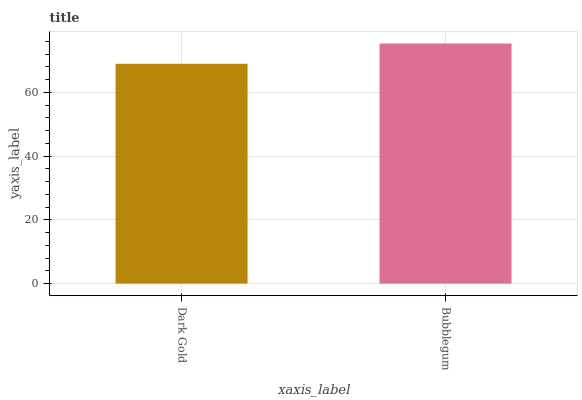Is Dark Gold the minimum?
Answer yes or no. Yes. Is Bubblegum the maximum?
Answer yes or no. Yes. Is Bubblegum the minimum?
Answer yes or no. No. Is Bubblegum greater than Dark Gold?
Answer yes or no. Yes. Is Dark Gold less than Bubblegum?
Answer yes or no. Yes. Is Dark Gold greater than Bubblegum?
Answer yes or no. No. Is Bubblegum less than Dark Gold?
Answer yes or no. No. Is Bubblegum the high median?
Answer yes or no. Yes. Is Dark Gold the low median?
Answer yes or no. Yes. Is Dark Gold the high median?
Answer yes or no. No. Is Bubblegum the low median?
Answer yes or no. No. 